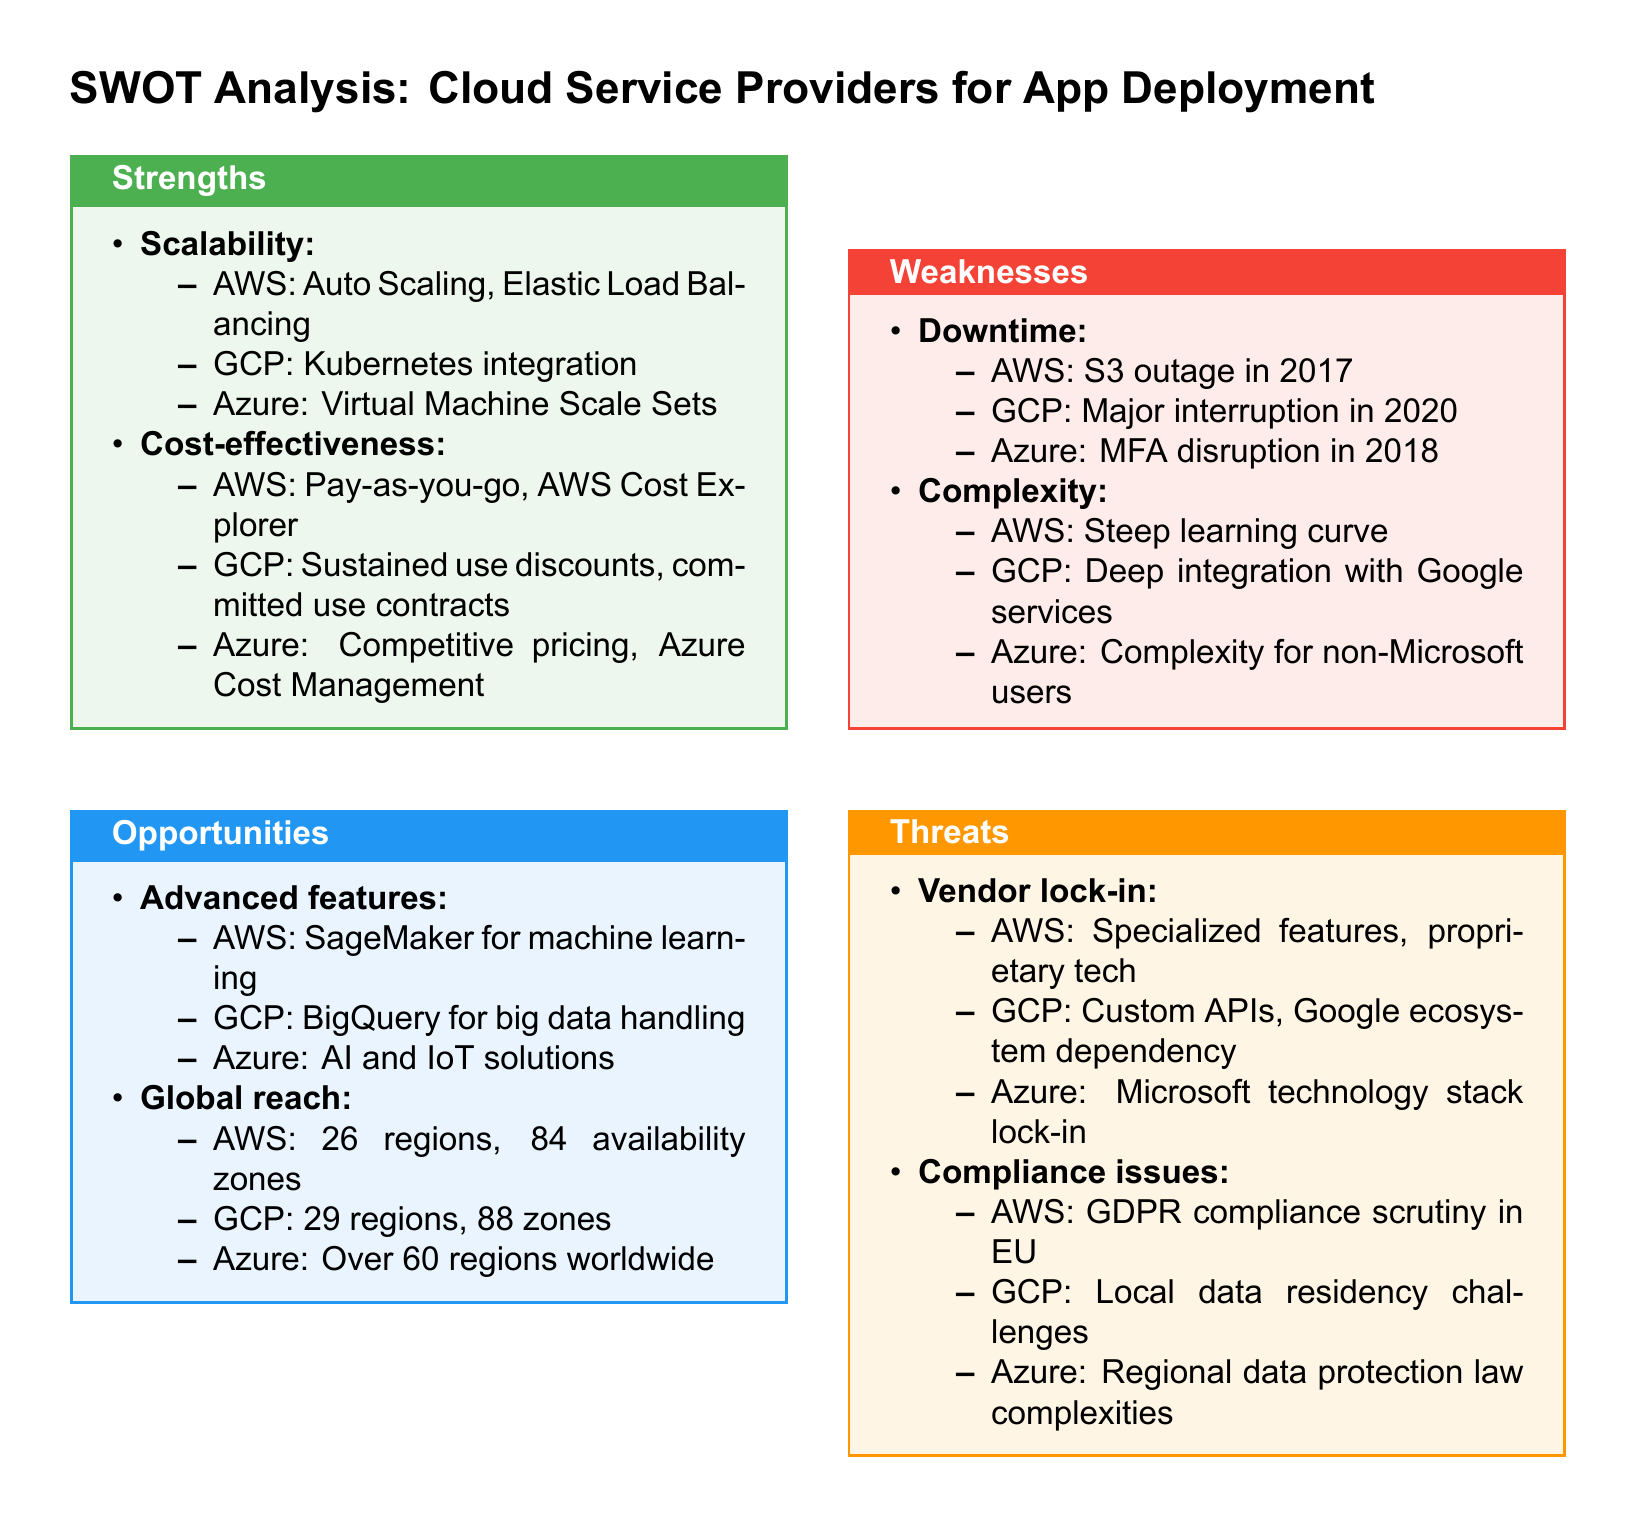What are the strengths of AWS? The strengths listed for AWS include Auto Scaling and Elastic Load Balancing under scalability, and pay-as-you-go and AWS Cost Explorer under cost-effectiveness.
Answer: Scalability, cost-effectiveness Which cloud service provider has the largest number of regions? The document specifies the number of regions for each provider, with GCP listed as having 29 regions.
Answer: GCP What is a major downtime incident for Azure mentioned in the document? The document states that there was an MFA disruption for Azure in 2018 as a notable downtime incident.
Answer: MFA disruption in 2018 What is the opportunity associated with AWS? AWS's opportunity listed in the document includes using SageMaker for machine learning as an advanced feature.
Answer: SageMaker for machine learning What is the document type of the analysis? The analysis format is specifically a SWOT analysis, which focuses on strengths, weaknesses, opportunities, and threats.
Answer: SWOT analysis What complexity issue is mentioned regarding AWS? The document notes that AWS has a steep learning curve as a complexity issue.
Answer: Steep learning curve Which compliance issue is raised for GCP? The document highlights local data residency challenges as a compliance issue for GCP.
Answer: Local data residency challenges What is a threat associated with vendor lock-in for Azure? Azure's threat includes Microsoft technology stack lock-in as a vendor lock-in issue.
Answer: Microsoft technology stack lock-in 